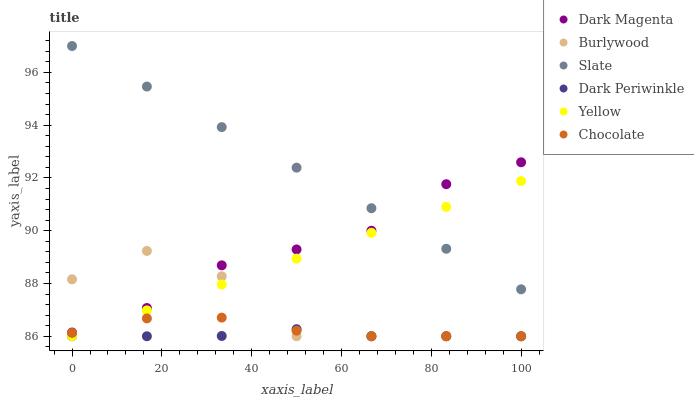Does Dark Periwinkle have the minimum area under the curve?
Answer yes or no. Yes. Does Slate have the maximum area under the curve?
Answer yes or no. Yes. Does Burlywood have the minimum area under the curve?
Answer yes or no. No. Does Burlywood have the maximum area under the curve?
Answer yes or no. No. Is Slate the smoothest?
Answer yes or no. Yes. Is Burlywood the roughest?
Answer yes or no. Yes. Is Burlywood the smoothest?
Answer yes or no. No. Is Slate the roughest?
Answer yes or no. No. Does Burlywood have the lowest value?
Answer yes or no. Yes. Does Slate have the lowest value?
Answer yes or no. No. Does Slate have the highest value?
Answer yes or no. Yes. Does Burlywood have the highest value?
Answer yes or no. No. Is Yellow less than Dark Magenta?
Answer yes or no. Yes. Is Slate greater than Chocolate?
Answer yes or no. Yes. Does Slate intersect Yellow?
Answer yes or no. Yes. Is Slate less than Yellow?
Answer yes or no. No. Is Slate greater than Yellow?
Answer yes or no. No. Does Yellow intersect Dark Magenta?
Answer yes or no. No. 